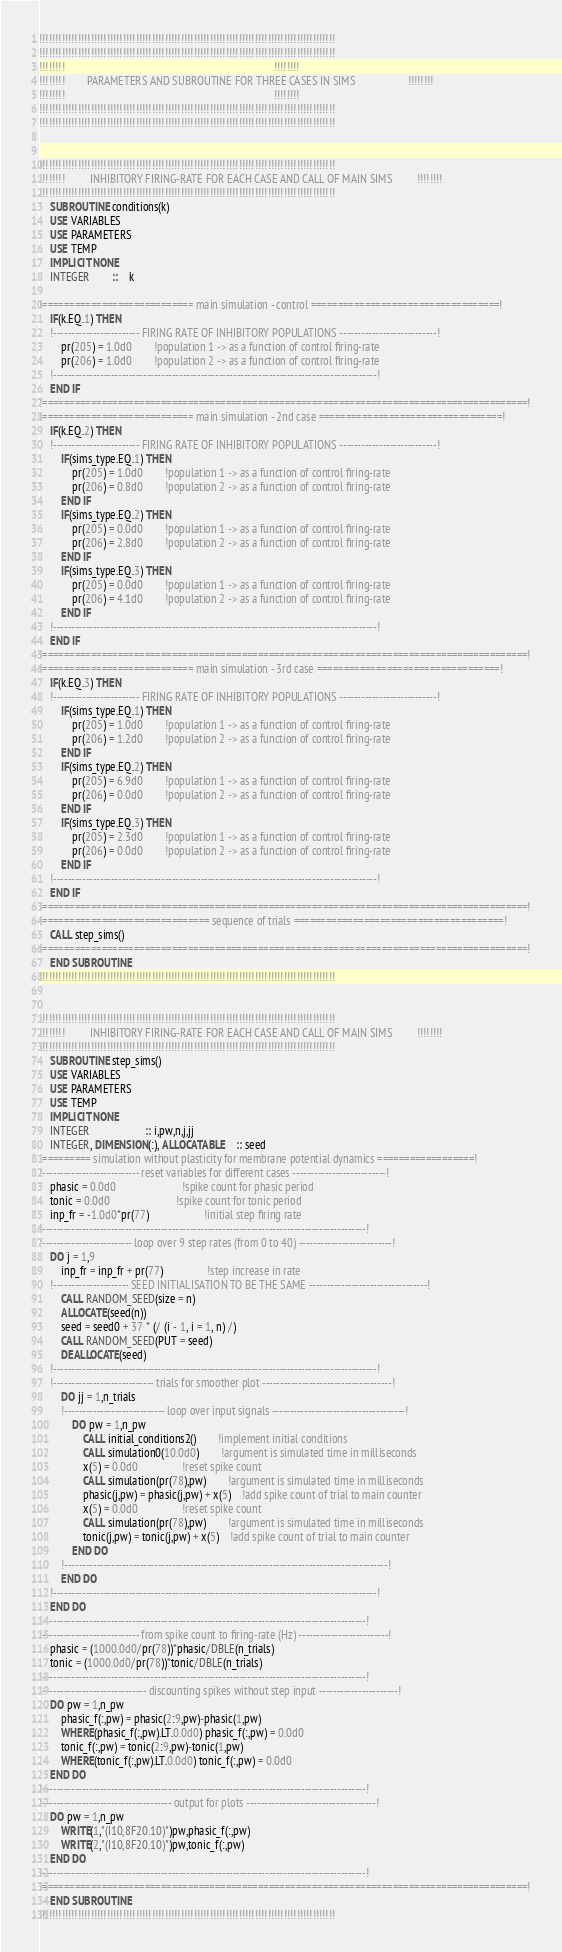<code> <loc_0><loc_0><loc_500><loc_500><_FORTRAN_>!!!!!!!!!!!!!!!!!!!!!!!!!!!!!!!!!!!!!!!!!!!!!!!!!!!!!!!!!!!!!!!!!!!!!!!!!!!!!!!!!!!!!!!!!!!!
!!!!!!!!!!!!!!!!!!!!!!!!!!!!!!!!!!!!!!!!!!!!!!!!!!!!!!!!!!!!!!!!!!!!!!!!!!!!!!!!!!!!!!!!!!!!
!!!!!!!!                                                                            !!!!!!!!
!!!!!!!!        PARAMETERS AND SUBROUTINE FOR THREE CASES IN SIMS                   !!!!!!!!
!!!!!!!!                                                                            !!!!!!!!
!!!!!!!!!!!!!!!!!!!!!!!!!!!!!!!!!!!!!!!!!!!!!!!!!!!!!!!!!!!!!!!!!!!!!!!!!!!!!!!!!!!!!!!!!!!!
!!!!!!!!!!!!!!!!!!!!!!!!!!!!!!!!!!!!!!!!!!!!!!!!!!!!!!!!!!!!!!!!!!!!!!!!!!!!!!!!!!!!!!!!!!!!


!!!!!!!!!!!!!!!!!!!!!!!!!!!!!!!!!!!!!!!!!!!!!!!!!!!!!!!!!!!!!!!!!!!!!!!!!!!!!!!!!!!!!!!!!!!!
!!!!!!!!         INHIBITORY FIRING-RATE FOR EACH CASE AND CALL OF MAIN SIMS         !!!!!!!!
!!!!!!!!!!!!!!!!!!!!!!!!!!!!!!!!!!!!!!!!!!!!!!!!!!!!!!!!!!!!!!!!!!!!!!!!!!!!!!!!!!!!!!!!!!!!
	SUBROUTINE conditions(k)
	USE VARIABLES
	USE PARAMETERS
	USE TEMP
	IMPLICIT NONE
	INTEGER		::	k

!============================ main simulation - control ===================================!
	IF(k.EQ.1) THEN
	!------------------------ FIRING RATE OF INHIBITORY POPULATIONS ---------------------------!
		pr(205) = 1.0d0		!population 1 -> as a function of control firing-rate
		pr(206) = 1.0d0		!population 2 -> as a function of control firing-rate
	!------------------------------------------------------------------------------------------!
	END IF
!==========================================================================================!
!============================ main simulation - 2nd case ==================================!
	IF(k.EQ.2) THEN
	!------------------------ FIRING RATE OF INHIBITORY POPULATIONS ---------------------------!
		IF(sims_type.EQ.1) THEN
			pr(205) = 1.0d0		!population 1 -> as a function of control firing-rate
			pr(206) = 0.8d0		!population 2 -> as a function of control firing-rate
		END IF
		IF(sims_type.EQ.2) THEN
			pr(205) = 0.0d0		!population 1 -> as a function of control firing-rate
			pr(206) = 2.8d0		!population 2 -> as a function of control firing-rate
		END IF
		IF(sims_type.EQ.3) THEN
			pr(205) = 0.0d0		!population 1 -> as a function of control firing-rate
			pr(206) = 4.1d0		!population 2 -> as a function of control firing-rate
		END IF
	!------------------------------------------------------------------------------------------!
	END IF
!==========================================================================================!
!============================ main simulation - 3rd case ==================================!
	IF(k.EQ.3) THEN
	!------------------------ FIRING RATE OF INHIBITORY POPULATIONS ---------------------------!
		IF(sims_type.EQ.1) THEN
			pr(205) = 1.0d0		!population 1 -> as a function of control firing-rate
			pr(206) = 1.2d0		!population 2 -> as a function of control firing-rate
		END IF
		IF(sims_type.EQ.2) THEN
			pr(205) = 6.9d0		!population 1 -> as a function of control firing-rate
			pr(206) = 0.0d0		!population 2 -> as a function of control firing-rate
		END IF
		IF(sims_type.EQ.3) THEN
			pr(205) = 2.3d0		!population 1 -> as a function of control firing-rate
			pr(206) = 0.0d0		!population 2 -> as a function of control firing-rate
		END IF
	!------------------------------------------------------------------------------------------!
	END IF
!==========================================================================================!
!=============================== sequence of trials =======================================!
	CALL step_sims()
!==========================================================================================!
	END SUBROUTINE
!!!!!!!!!!!!!!!!!!!!!!!!!!!!!!!!!!!!!!!!!!!!!!!!!!!!!!!!!!!!!!!!!!!!!!!!!!!!!!!!!!!!!!!!!!!!


!!!!!!!!!!!!!!!!!!!!!!!!!!!!!!!!!!!!!!!!!!!!!!!!!!!!!!!!!!!!!!!!!!!!!!!!!!!!!!!!!!!!!!!!!!!!
!!!!!!!!         INHIBITORY FIRING-RATE FOR EACH CASE AND CALL OF MAIN SIMS         !!!!!!!!
!!!!!!!!!!!!!!!!!!!!!!!!!!!!!!!!!!!!!!!!!!!!!!!!!!!!!!!!!!!!!!!!!!!!!!!!!!!!!!!!!!!!!!!!!!!!
	SUBROUTINE step_sims()
	USE VARIABLES
	USE PARAMETERS
	USE TEMP
	IMPLICIT NONE
	INTEGER					:: i,pw,n,j,jj
	INTEGER, DIMENSION(:), ALLOCATABLE	:: seed
!========= simulation without plasticity for membrane potential dynamics ==================!
!--------------------------- reset variables for different cases --------------------------!
	phasic = 0.0d0						!spike count for phasic period
	tonic = 0.0d0						!spike count for tonic period
	inp_fr = -1.0d0*pr(77)					!initial step firing rate
!------------------------------------------------------------------------------------------!
!------------------------- loop over 9 step rates (from 0 to 40) --------------------------!
	DO j = 1,9
		inp_fr = inp_fr + pr(77)				!step increase in rate
	!--------------------- SEED INITIALISATION TO BE THE SAME ---------------------------------!
		CALL RANDOM_SEED(size = n)
		ALLOCATE(seed(n))
		seed = seed0 + 37 * (/ (i - 1, i = 1, n) /)
		CALL RANDOM_SEED(PUT = seed)
		DEALLOCATE(seed)
	!------------------------------------------------------------------------------------------!
	!---------------------------- trials for smoother plot ------------------------------------!
		DO jj = 1,n_trials
		!---------------------------- loop over input signals -------------------------------------!
			DO pw = 1,n_pw
				CALL initial_conditions2()		!implement initial conditions
				CALL simulation0(10.0d0)		!argument is simulated time in milliseconds
				x(5) = 0.0d0				!reset spike count
				CALL simulation(pr(78),pw)		!argument is simulated time in milliseconds
				phasic(j,pw) = phasic(j,pw) + x(5)	!add spike count of trial to main counter
				x(5) = 0.0d0				!reset spike count
				CALL simulation(pr(78),pw)		!argument is simulated time in milliseconds
				tonic(j,pw) = tonic(j,pw) + x(5)	!add spike count of trial to main counter
			END DO
		!------------------------------------------------------------------------------------------!
		END DO
	!------------------------------------------------------------------------------------------!
	END DO
!------------------------------------------------------------------------------------------!
!--------------------------- from spike count to firing-rate (Hz) -------------------------!
	phasic = (1000.0d0/pr(78))*phasic/DBLE(n_trials)
	tonic = (1000.0d0/pr(78))*tonic/DBLE(n_trials)
!------------------------------------------------------------------------------------------!
!----------------------------- discounting spikes without step input ----------------------!
	DO pw = 1,n_pw
		phasic_f(:,pw) = phasic(2:9,pw)-phasic(1,pw)
		WHERE(phasic_f(:,pw).LT.0.0d0) phasic_f(:,pw) = 0.0d0
		tonic_f(:,pw) = tonic(2:9,pw)-tonic(1,pw)
		WHERE(tonic_f(:,pw).LT.0.0d0) tonic_f(:,pw) = 0.0d0
	END DO
!------------------------------------------------------------------------------------------!
!------------------------------------ output for plots ------------------------------------!
	DO pw = 1,n_pw
		WRITE(1,"(I10,8F20.10)")pw,phasic_f(:,pw)
		WRITE(2,"(I10,8F20.10)")pw,tonic_f(:,pw)
	END DO
!------------------------------------------------------------------------------------------!
!==========================================================================================!
	END SUBROUTINE
!!!!!!!!!!!!!!!!!!!!!!!!!!!!!!!!!!!!!!!!!!!!!!!!!!!!!!!!!!!!!!!!!!!!!!!!!!!!!!!!!!!!!!!!!!!!
</code> 